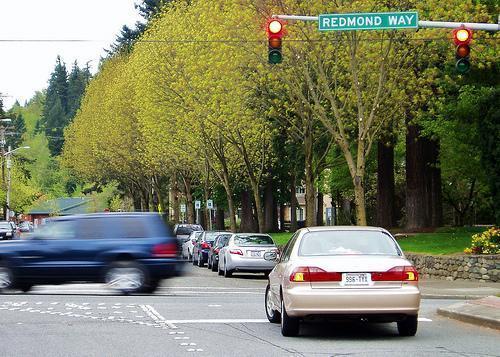How many cars are crossing the street?
Give a very brief answer. 1. How many red lights are shown?
Give a very brief answer. 2. 